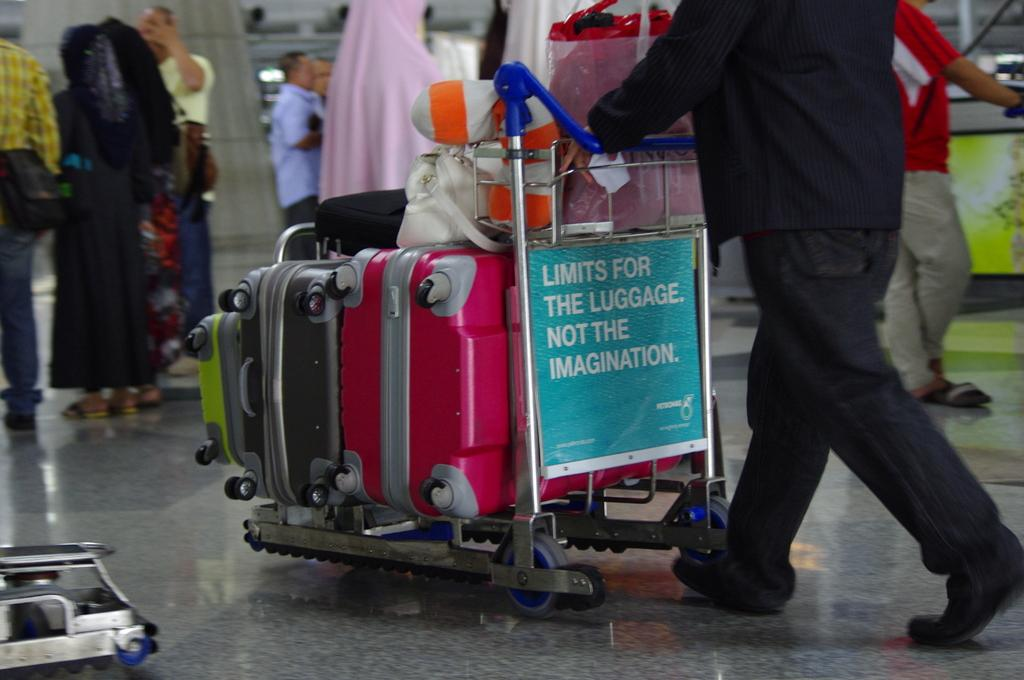What is the main object in the image? There is a trolley in the image. What is placed on the trolley? Luggage bags are placed on the trolley. Who is interacting with the trolley? One man is pushing the trolley. What can be seen in the background of the image? There are people standing in the background of the image. How does the trolley increase in size as it moves through the image? The trolley does not increase in size as it moves through the image; it remains the same size. 